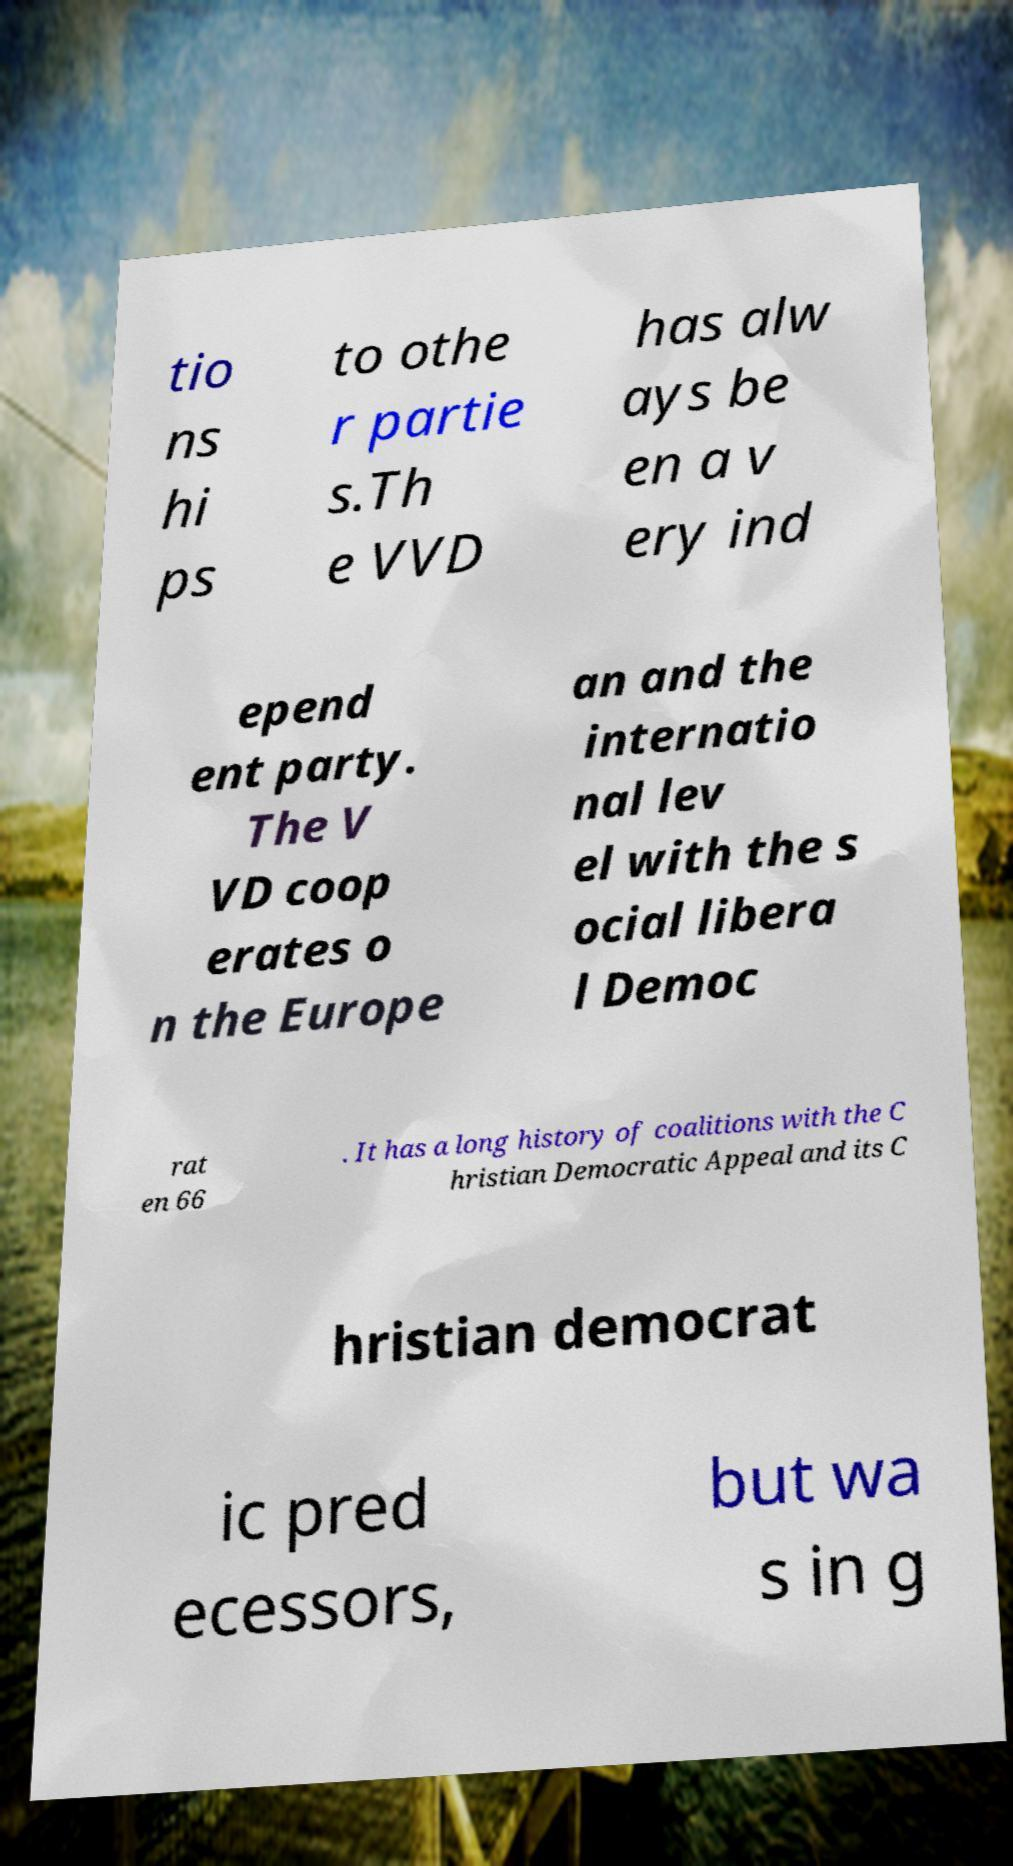Please read and relay the text visible in this image. What does it say? tio ns hi ps to othe r partie s.Th e VVD has alw ays be en a v ery ind epend ent party. The V VD coop erates o n the Europe an and the internatio nal lev el with the s ocial libera l Democ rat en 66 . It has a long history of coalitions with the C hristian Democratic Appeal and its C hristian democrat ic pred ecessors, but wa s in g 